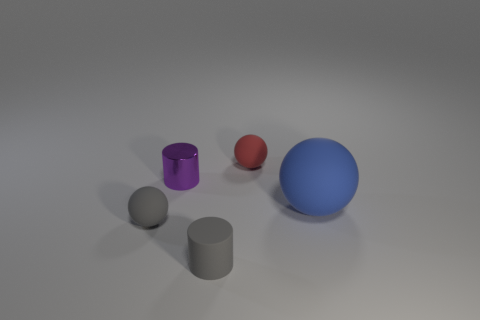What is the material of the sphere that is the same color as the small rubber cylinder?
Your answer should be very brief. Rubber. There is a matte object in front of the tiny rubber sphere in front of the sphere that is behind the purple shiny cylinder; what is its color?
Offer a terse response. Gray. What number of metal objects are red objects or small gray objects?
Your answer should be very brief. 0. Do the red ball and the rubber cylinder have the same size?
Your response must be concise. Yes. Is the number of blue matte spheres that are on the left side of the large blue matte thing less than the number of balls left of the gray matte sphere?
Your answer should be very brief. No. Is there anything else that is the same size as the purple object?
Provide a short and direct response. Yes. What is the size of the metal thing?
Ensure brevity in your answer.  Small. How many tiny things are blue rubber things or gray metallic cylinders?
Your response must be concise. 0. Do the gray cylinder and the gray thing that is to the left of the metal cylinder have the same size?
Offer a very short reply. Yes. Is there anything else that is the same shape as the purple thing?
Offer a terse response. Yes. 